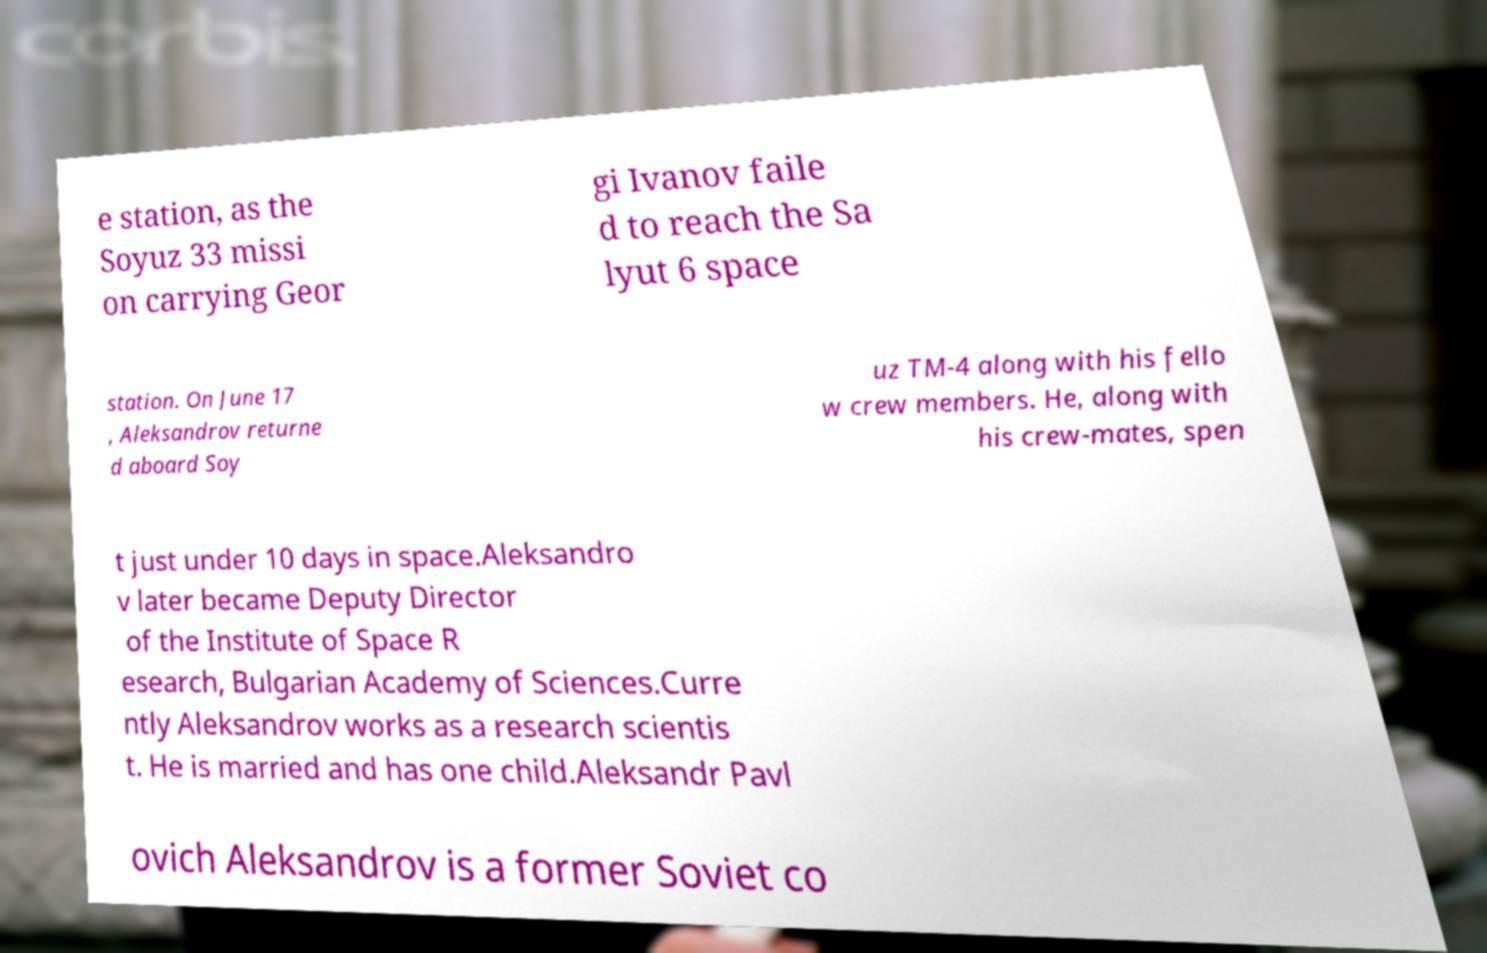Please read and relay the text visible in this image. What does it say? e station, as the Soyuz 33 missi on carrying Geor gi Ivanov faile d to reach the Sa lyut 6 space station. On June 17 , Aleksandrov returne d aboard Soy uz TM-4 along with his fello w crew members. He, along with his crew-mates, spen t just under 10 days in space.Aleksandro v later became Deputy Director of the Institute of Space R esearch, Bulgarian Academy of Sciences.Curre ntly Aleksandrov works as a research scientis t. He is married and has one child.Aleksandr Pavl ovich Aleksandrov is a former Soviet co 